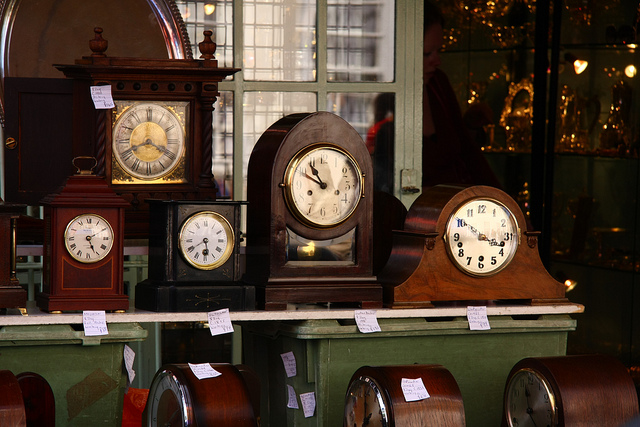Identify and read out the text in this image. 12 10 9 2 5 5 7 3 4 5 6 8 